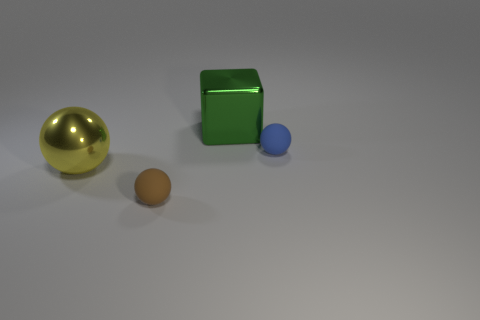If this image were part of an art exhibit, what title would you give it and why? A fitting title for this exhibit piece might be 'Simplicity in Form.' This title encapsulates the image's focus on basic geometric shapes and the straightforward presentation. Each shape's distinct color and texture, coupled with the interplay of light and shadow, contribute to a simple yet evocative display that invites contemplation on the fundamentals of form and space. 